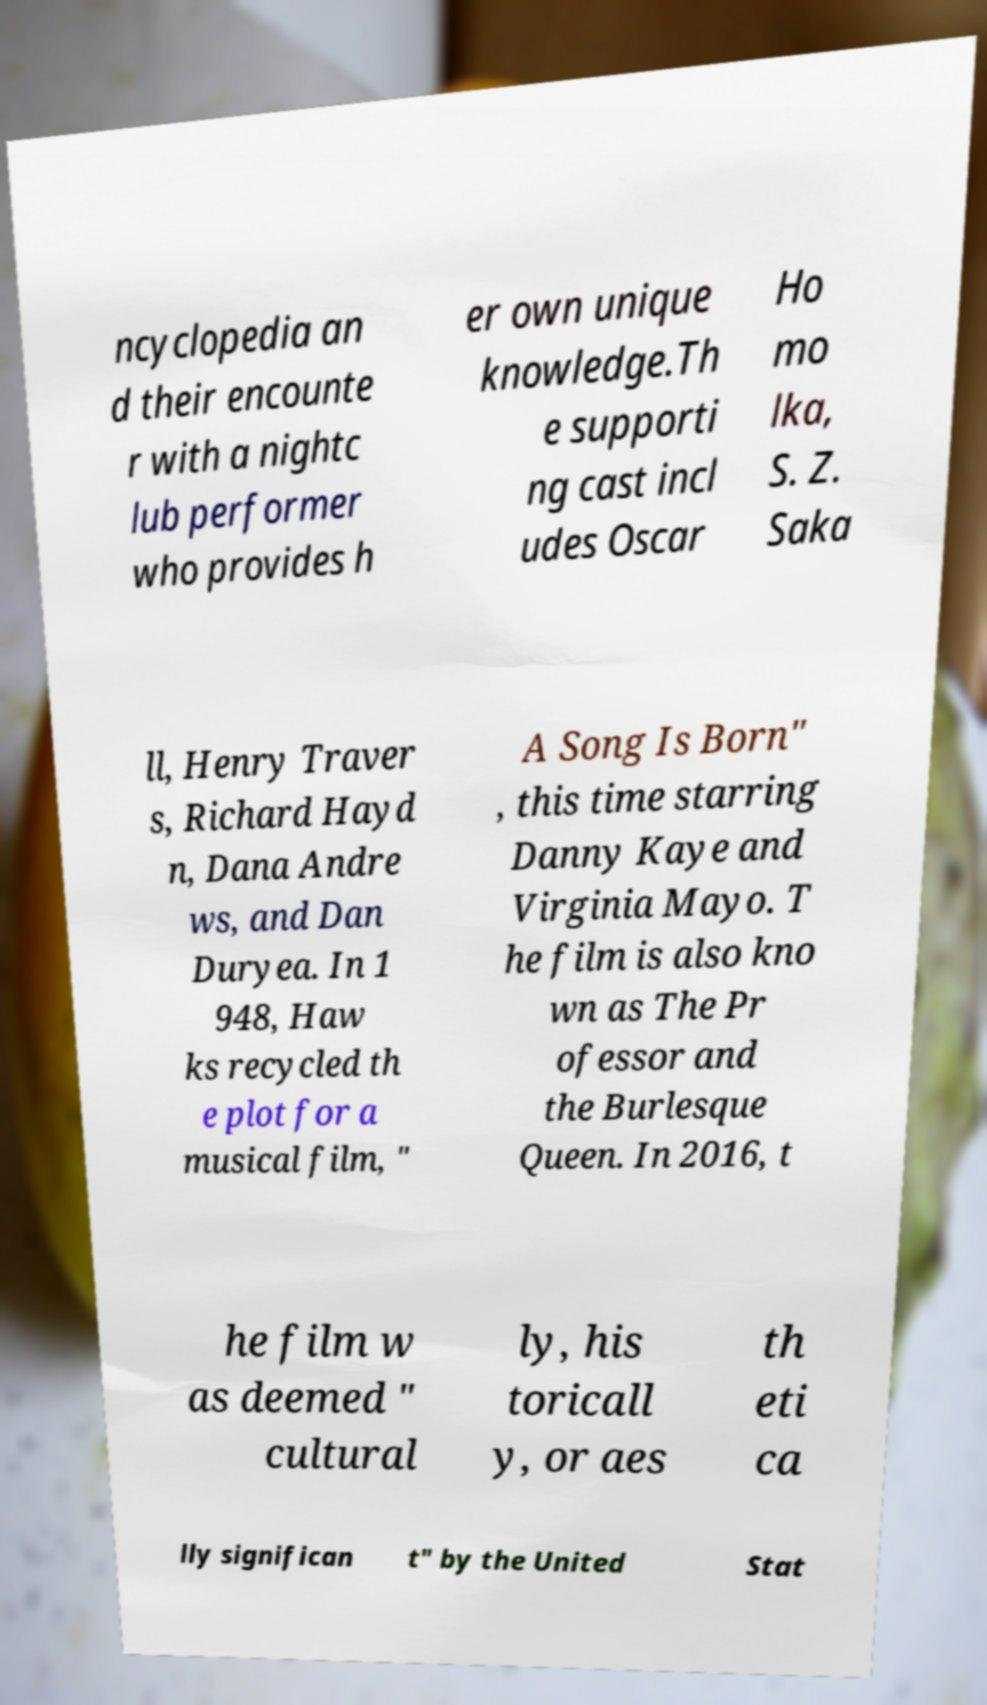For documentation purposes, I need the text within this image transcribed. Could you provide that? ncyclopedia an d their encounte r with a nightc lub performer who provides h er own unique knowledge.Th e supporti ng cast incl udes Oscar Ho mo lka, S. Z. Saka ll, Henry Traver s, Richard Hayd n, Dana Andre ws, and Dan Duryea. In 1 948, Haw ks recycled th e plot for a musical film, " A Song Is Born" , this time starring Danny Kaye and Virginia Mayo. T he film is also kno wn as The Pr ofessor and the Burlesque Queen. In 2016, t he film w as deemed " cultural ly, his toricall y, or aes th eti ca lly significan t" by the United Stat 